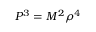Convert formula to latex. <formula><loc_0><loc_0><loc_500><loc_500>P ^ { 3 } = M ^ { 2 } \rho ^ { 4 }</formula> 